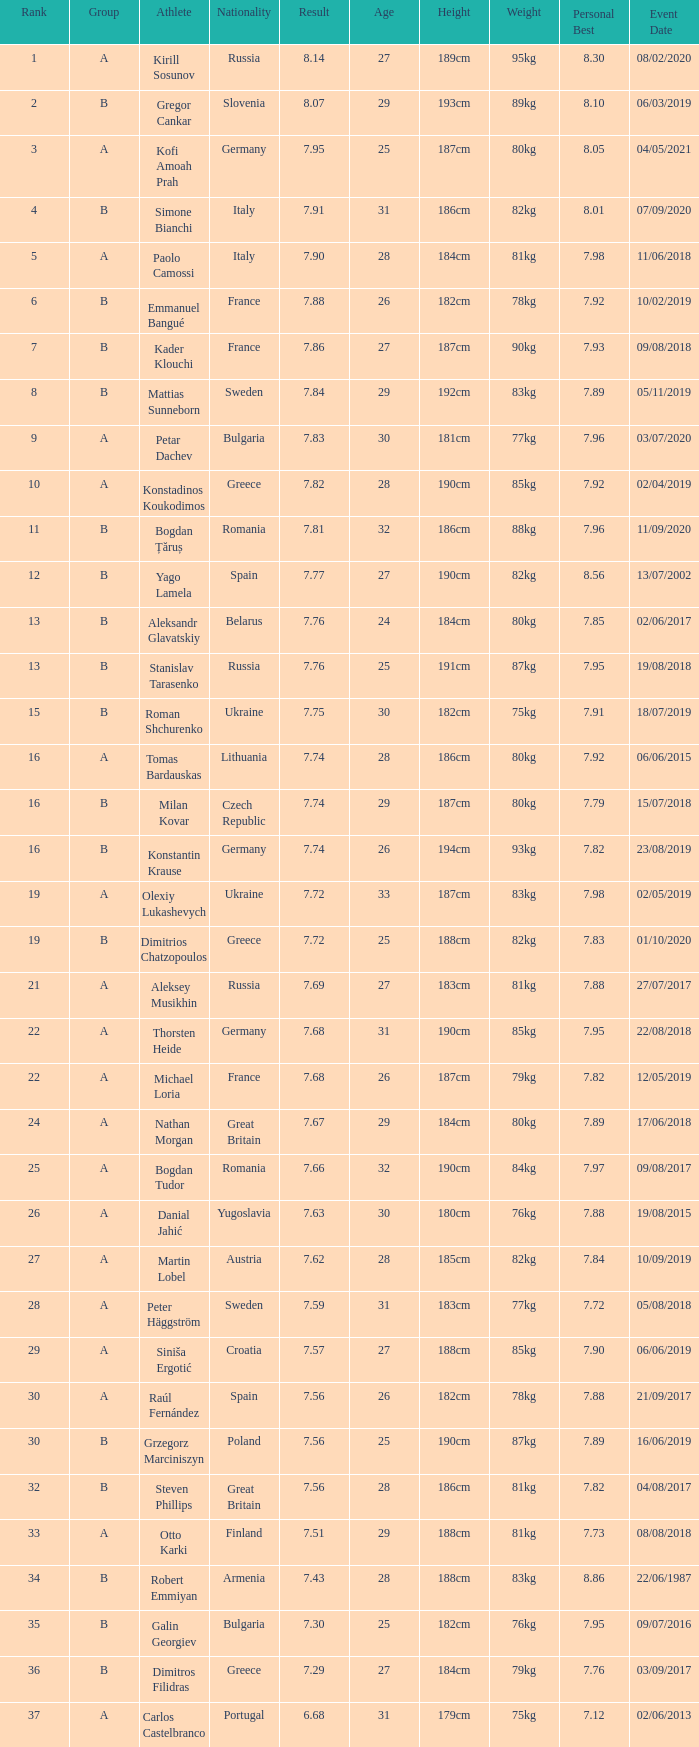Which athlete's rank is more than 15 when the result is less than 7.68, the group is b, and the nationality listed is Great Britain? Steven Phillips. 